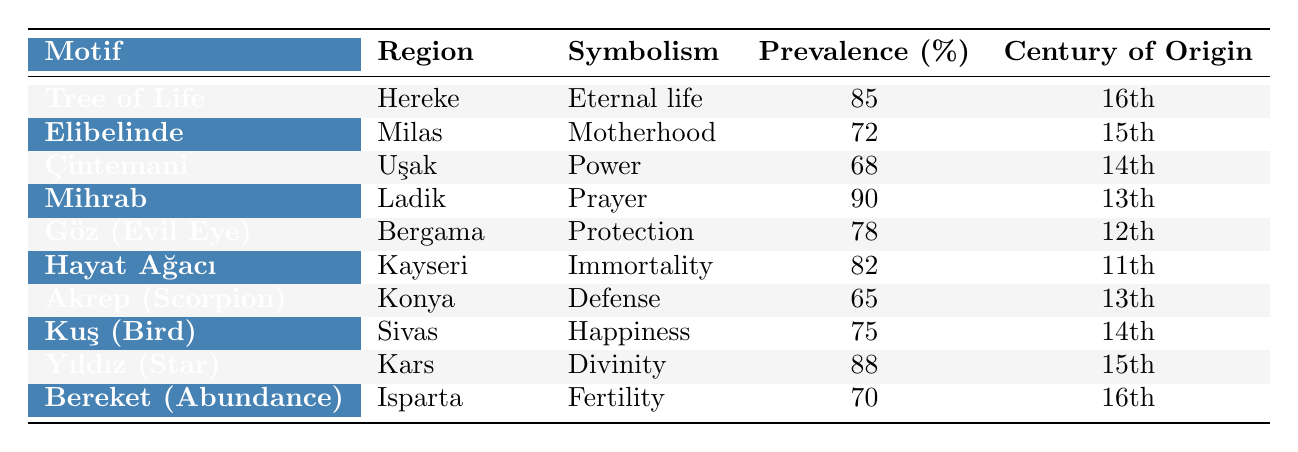What is the motif with the highest prevalence? The table lists the prevalence of each motif. By scanning through the "Prevalence (%)" column, we see that "Mihrab" has the highest prevalence at 90%.
Answer: Mihrab Which region is known for the "Elibelinde" motif? The table specifies the region for each motif. Looking at the "Region" column corresponding to "Elibelinde," it is listed under "Milas."
Answer: Milas How many motifs originate from the 13th century? To find the number of motifs from the 13th century, we look for the rows where "Century of Origin" is listed as 13. There are two motifs: "Mihrab" and "Akrep (Scorpion)."
Answer: 2 What is the symbolism of the "Göz (Evil Eye)" motif? The symbolism of each motif is provided in the "Symbolism" column. For "Göz (Evil Eye)," it is noted as "Protection."
Answer: Protection Are there any motifs with a prevalence above 80%? We can check the prevalence percentages in the table. "Mihrab" (90%), "Tree of Life" (85%), and "Yıldız (Star)" (88%) are all above 80%.
Answer: Yes What is the average prevalence of motifs from the 15th century? We first identify the motifs from the 15th century: "Elibelinde" (72%) and "Yıldız (Star)" (88%). Then, we calculate the average: (72 + 88) / 2 = 80.
Answer: 80 Which motif symbolizes "Motherhood"? The table contains the symbolism for each motif. We look for the entry with the symbolism "Motherhood," which corresponds to "Elibelinde."
Answer: Elibelinde Does the "Hayat Ağacı" motif have a higher prevalence than the "Kuş (Bird)" motif? We compare the prevalence values in the table: "Hayat Ağacı" has 82% and "Kuş (Bird)" has 75%. Since 82 is greater than 75, the answer is yes.
Answer: Yes What is the total prevalence percentage of motifs originating from the 16th century? The motifs from the 16th century are "Tree of Life" (85%) and "Bereket (Abundance)" (70%). Adding these gives us a total of 85 + 70 = 155.
Answer: 155 